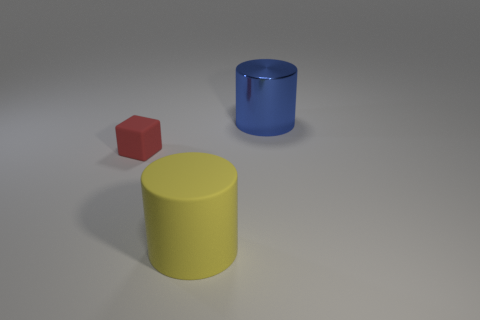Is there any other thing that has the same material as the large blue object?
Provide a short and direct response. No. How many big objects are cylinders or gray rubber balls?
Give a very brief answer. 2. The block has what color?
Your response must be concise. Red. The large object on the left side of the large cylinder that is behind the block is what shape?
Ensure brevity in your answer.  Cylinder. Is there a cyan thing made of the same material as the red thing?
Ensure brevity in your answer.  No. There is a cylinder that is in front of the red matte cube; is it the same size as the small object?
Your response must be concise. No. What number of purple objects are tiny matte blocks or big rubber objects?
Offer a very short reply. 0. What is the material of the cylinder behind the small red rubber object?
Offer a very short reply. Metal. How many large rubber cylinders are in front of the big thing that is in front of the shiny thing?
Give a very brief answer. 0. What number of big things are the same shape as the small rubber object?
Provide a short and direct response. 0. 